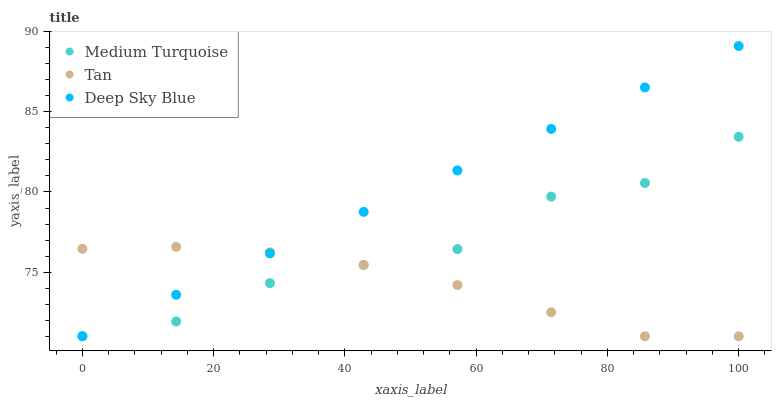Does Tan have the minimum area under the curve?
Answer yes or no. Yes. Does Deep Sky Blue have the maximum area under the curve?
Answer yes or no. Yes. Does Medium Turquoise have the minimum area under the curve?
Answer yes or no. No. Does Medium Turquoise have the maximum area under the curve?
Answer yes or no. No. Is Deep Sky Blue the smoothest?
Answer yes or no. Yes. Is Medium Turquoise the roughest?
Answer yes or no. Yes. Is Medium Turquoise the smoothest?
Answer yes or no. No. Is Deep Sky Blue the roughest?
Answer yes or no. No. Does Tan have the lowest value?
Answer yes or no. Yes. Does Deep Sky Blue have the highest value?
Answer yes or no. Yes. Does Medium Turquoise have the highest value?
Answer yes or no. No. Does Deep Sky Blue intersect Tan?
Answer yes or no. Yes. Is Deep Sky Blue less than Tan?
Answer yes or no. No. Is Deep Sky Blue greater than Tan?
Answer yes or no. No. 